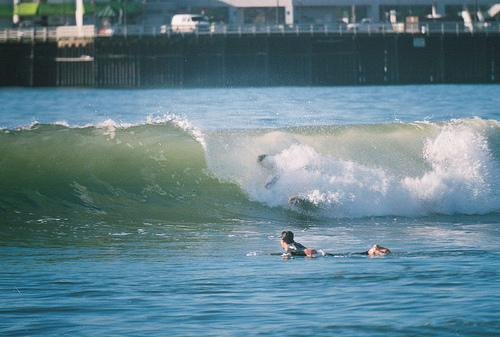Question: how many people are in this photo?
Choices:
A. Five.
B. Four.
C. Two.
D. Seven.
Answer with the letter. Answer: C Question: where is the second person?
Choices:
A. On the beach.
B. Under the wave.
C. On the deck.
D. Under the deck.
Answer with the letter. Answer: B Question: how many people are under a wave?
Choices:
A. Two.
B. Three.
C. One.
D. Six.
Answer with the letter. Answer: C Question: where was this photo taken?
Choices:
A. In the lake.
B. In the ocean.
C. In the sound.
D. In the bay.
Answer with the letter. Answer: B Question: what is behind the water?
Choices:
A. Mountains.
B. A wall and elevated buildings.
C. Skyscrapers.
D. Beach.
Answer with the letter. Answer: B Question: what color is the wall?
Choices:
A. Black.
B. Grey.
C. Brown.
D. Green.
Answer with the letter. Answer: A 